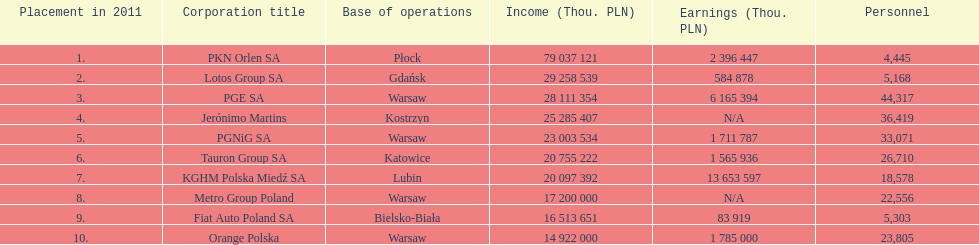What company is the only one with a revenue greater than 75,000,000 thou. pln? PKN Orlen SA. 